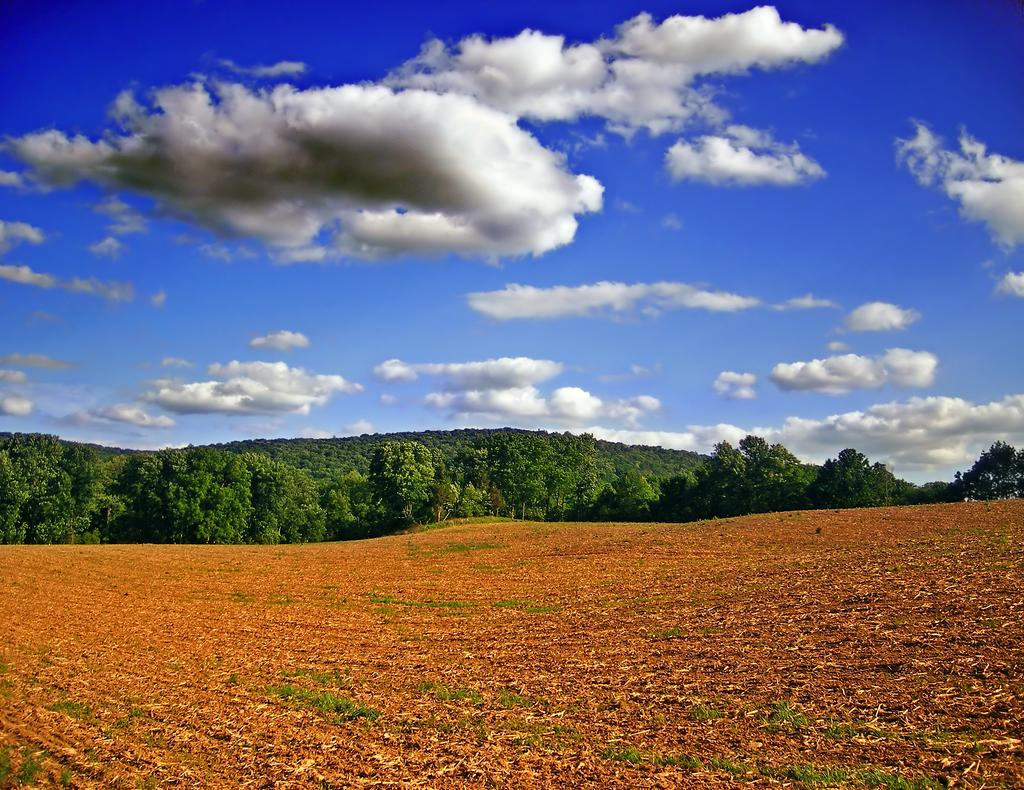What type of vegetation can be seen in the image? There are trees in the image. What part of the natural environment is visible at the bottom of the image? The ground is visible at the bottom of the image. What is visible in the sky at the top of the image? There are clouds in the sky at the top of the image. How many cups can be seen in the image? There are no cups present in the image. Are there any girls visible in the image? There are no girls present in the image. 